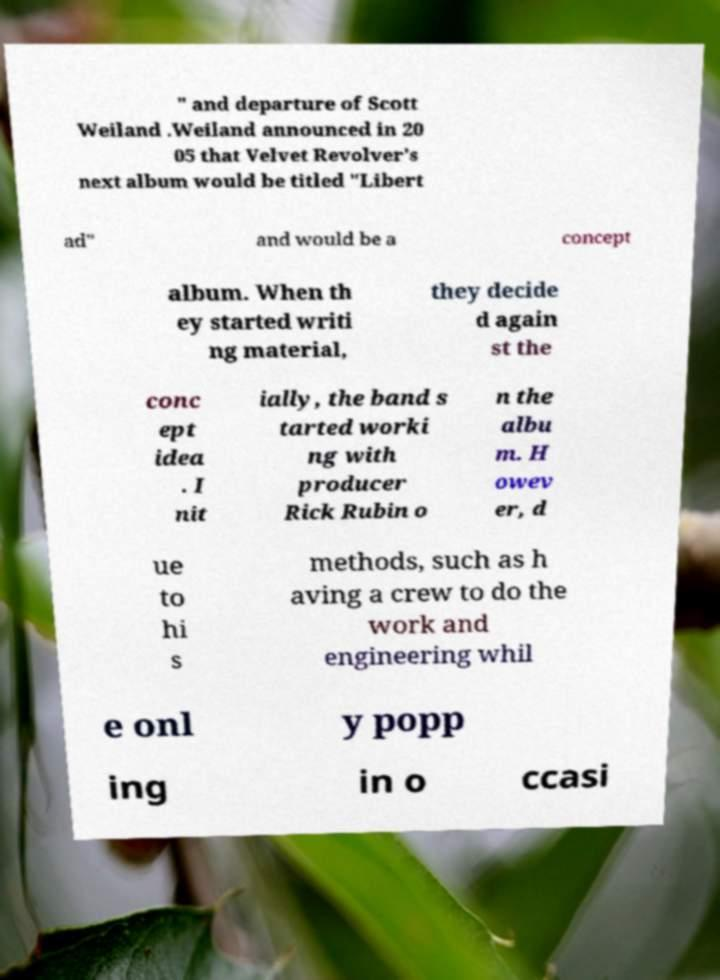Can you read and provide the text displayed in the image?This photo seems to have some interesting text. Can you extract and type it out for me? " and departure of Scott Weiland .Weiland announced in 20 05 that Velvet Revolver's next album would be titled "Libert ad" and would be a concept album. When th ey started writi ng material, they decide d again st the conc ept idea . I nit ially, the band s tarted worki ng with producer Rick Rubin o n the albu m. H owev er, d ue to hi s methods, such as h aving a crew to do the work and engineering whil e onl y popp ing in o ccasi 